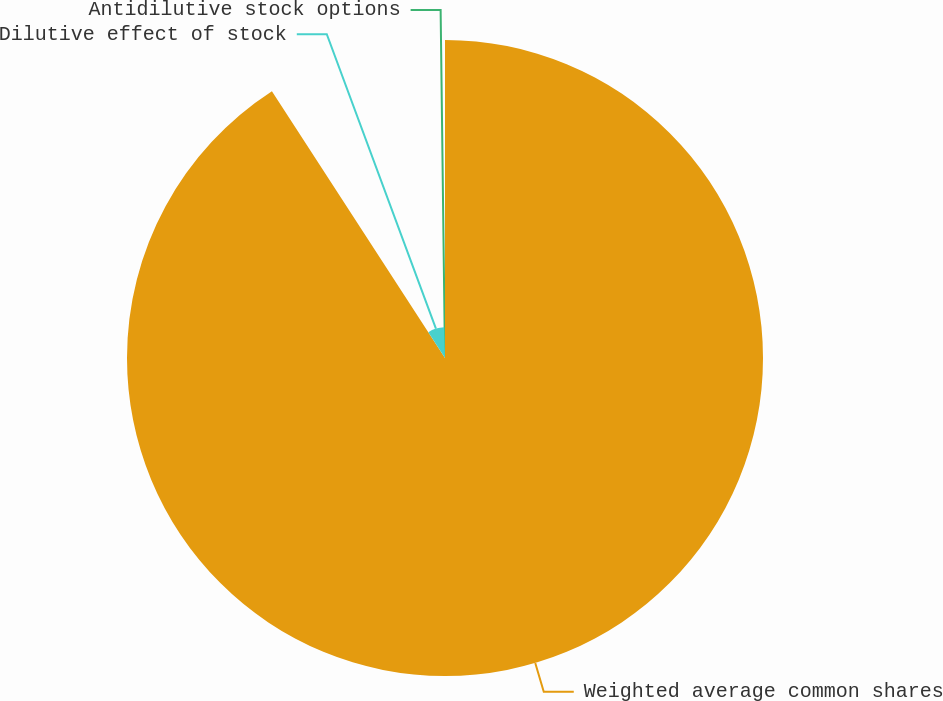Convert chart. <chart><loc_0><loc_0><loc_500><loc_500><pie_chart><fcel>Weighted average common shares<fcel>Dilutive effect of stock<fcel>Antidilutive stock options<nl><fcel>90.84%<fcel>8.76%<fcel>0.4%<nl></chart> 